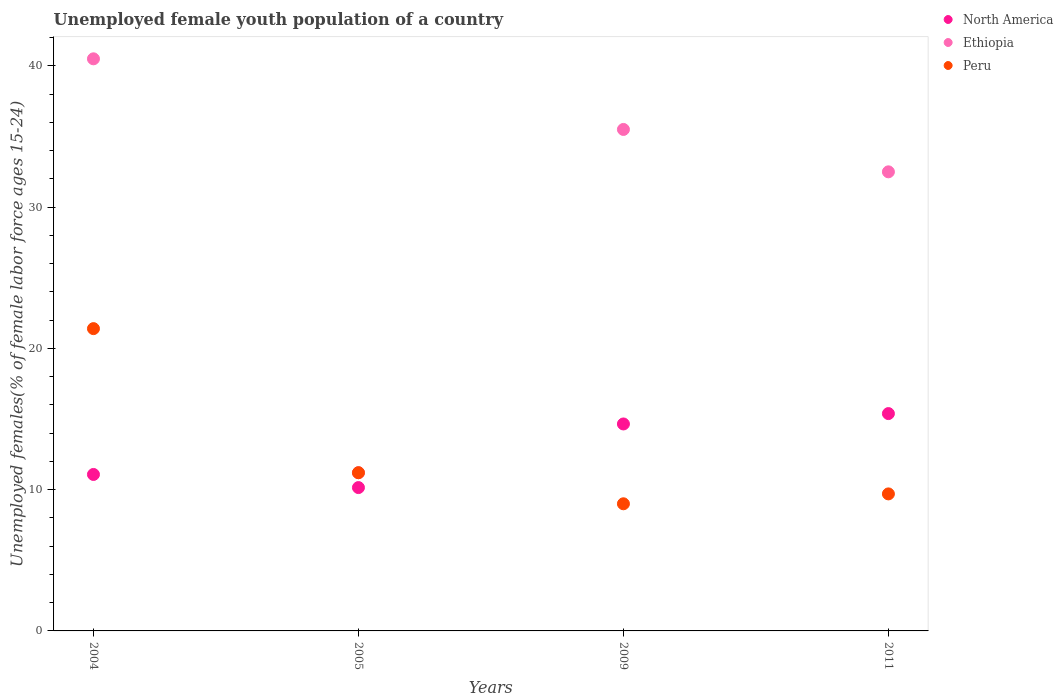Is the number of dotlines equal to the number of legend labels?
Give a very brief answer. Yes. What is the percentage of unemployed female youth population in Ethiopia in 2004?
Your response must be concise. 40.5. Across all years, what is the maximum percentage of unemployed female youth population in Peru?
Your answer should be very brief. 21.4. In which year was the percentage of unemployed female youth population in North America minimum?
Provide a succinct answer. 2005. What is the total percentage of unemployed female youth population in Peru in the graph?
Make the answer very short. 51.3. What is the difference between the percentage of unemployed female youth population in North America in 2005 and that in 2011?
Give a very brief answer. -5.24. What is the difference between the percentage of unemployed female youth population in North America in 2004 and the percentage of unemployed female youth population in Ethiopia in 2005?
Provide a short and direct response. -0.12. What is the average percentage of unemployed female youth population in Ethiopia per year?
Your answer should be very brief. 29.92. In the year 2009, what is the difference between the percentage of unemployed female youth population in Ethiopia and percentage of unemployed female youth population in Peru?
Provide a succinct answer. 26.5. What is the ratio of the percentage of unemployed female youth population in North America in 2009 to that in 2011?
Give a very brief answer. 0.95. What is the difference between the highest and the second highest percentage of unemployed female youth population in North America?
Your answer should be compact. 0.73. What is the difference between the highest and the lowest percentage of unemployed female youth population in Ethiopia?
Give a very brief answer. 29.3. In how many years, is the percentage of unemployed female youth population in North America greater than the average percentage of unemployed female youth population in North America taken over all years?
Offer a very short reply. 2. Is the sum of the percentage of unemployed female youth population in North America in 2004 and 2005 greater than the maximum percentage of unemployed female youth population in Peru across all years?
Give a very brief answer. No. Does the percentage of unemployed female youth population in Ethiopia monotonically increase over the years?
Provide a succinct answer. No. What is the difference between two consecutive major ticks on the Y-axis?
Offer a very short reply. 10. Are the values on the major ticks of Y-axis written in scientific E-notation?
Provide a succinct answer. No. Does the graph contain any zero values?
Ensure brevity in your answer.  No. Does the graph contain grids?
Your answer should be very brief. No. How are the legend labels stacked?
Your answer should be compact. Vertical. What is the title of the graph?
Provide a succinct answer. Unemployed female youth population of a country. What is the label or title of the X-axis?
Your answer should be very brief. Years. What is the label or title of the Y-axis?
Your response must be concise. Unemployed females(% of female labor force ages 15-24). What is the Unemployed females(% of female labor force ages 15-24) in North America in 2004?
Provide a short and direct response. 11.08. What is the Unemployed females(% of female labor force ages 15-24) of Ethiopia in 2004?
Make the answer very short. 40.5. What is the Unemployed females(% of female labor force ages 15-24) in Peru in 2004?
Provide a succinct answer. 21.4. What is the Unemployed females(% of female labor force ages 15-24) of North America in 2005?
Offer a terse response. 10.15. What is the Unemployed females(% of female labor force ages 15-24) of Ethiopia in 2005?
Your response must be concise. 11.2. What is the Unemployed females(% of female labor force ages 15-24) of Peru in 2005?
Your response must be concise. 11.2. What is the Unemployed females(% of female labor force ages 15-24) in North America in 2009?
Provide a short and direct response. 14.65. What is the Unemployed females(% of female labor force ages 15-24) of Ethiopia in 2009?
Provide a succinct answer. 35.5. What is the Unemployed females(% of female labor force ages 15-24) in North America in 2011?
Keep it short and to the point. 15.39. What is the Unemployed females(% of female labor force ages 15-24) in Ethiopia in 2011?
Your answer should be very brief. 32.5. What is the Unemployed females(% of female labor force ages 15-24) of Peru in 2011?
Offer a terse response. 9.7. Across all years, what is the maximum Unemployed females(% of female labor force ages 15-24) in North America?
Ensure brevity in your answer.  15.39. Across all years, what is the maximum Unemployed females(% of female labor force ages 15-24) in Ethiopia?
Your answer should be very brief. 40.5. Across all years, what is the maximum Unemployed females(% of female labor force ages 15-24) of Peru?
Keep it short and to the point. 21.4. Across all years, what is the minimum Unemployed females(% of female labor force ages 15-24) in North America?
Offer a terse response. 10.15. Across all years, what is the minimum Unemployed females(% of female labor force ages 15-24) of Ethiopia?
Your answer should be compact. 11.2. What is the total Unemployed females(% of female labor force ages 15-24) of North America in the graph?
Your response must be concise. 51.26. What is the total Unemployed females(% of female labor force ages 15-24) of Ethiopia in the graph?
Ensure brevity in your answer.  119.7. What is the total Unemployed females(% of female labor force ages 15-24) of Peru in the graph?
Ensure brevity in your answer.  51.3. What is the difference between the Unemployed females(% of female labor force ages 15-24) in Ethiopia in 2004 and that in 2005?
Provide a short and direct response. 29.3. What is the difference between the Unemployed females(% of female labor force ages 15-24) in Peru in 2004 and that in 2005?
Your answer should be compact. 10.2. What is the difference between the Unemployed females(% of female labor force ages 15-24) of North America in 2004 and that in 2009?
Provide a succinct answer. -3.58. What is the difference between the Unemployed females(% of female labor force ages 15-24) in Ethiopia in 2004 and that in 2009?
Keep it short and to the point. 5. What is the difference between the Unemployed females(% of female labor force ages 15-24) in North America in 2004 and that in 2011?
Your response must be concise. -4.31. What is the difference between the Unemployed females(% of female labor force ages 15-24) in Peru in 2004 and that in 2011?
Provide a short and direct response. 11.7. What is the difference between the Unemployed females(% of female labor force ages 15-24) of North America in 2005 and that in 2009?
Offer a very short reply. -4.5. What is the difference between the Unemployed females(% of female labor force ages 15-24) of Ethiopia in 2005 and that in 2009?
Your response must be concise. -24.3. What is the difference between the Unemployed females(% of female labor force ages 15-24) in North America in 2005 and that in 2011?
Your response must be concise. -5.24. What is the difference between the Unemployed females(% of female labor force ages 15-24) in Ethiopia in 2005 and that in 2011?
Keep it short and to the point. -21.3. What is the difference between the Unemployed females(% of female labor force ages 15-24) of Peru in 2005 and that in 2011?
Make the answer very short. 1.5. What is the difference between the Unemployed females(% of female labor force ages 15-24) of North America in 2009 and that in 2011?
Give a very brief answer. -0.73. What is the difference between the Unemployed females(% of female labor force ages 15-24) of Ethiopia in 2009 and that in 2011?
Your response must be concise. 3. What is the difference between the Unemployed females(% of female labor force ages 15-24) in Peru in 2009 and that in 2011?
Your response must be concise. -0.7. What is the difference between the Unemployed females(% of female labor force ages 15-24) of North America in 2004 and the Unemployed females(% of female labor force ages 15-24) of Ethiopia in 2005?
Your answer should be very brief. -0.12. What is the difference between the Unemployed females(% of female labor force ages 15-24) in North America in 2004 and the Unemployed females(% of female labor force ages 15-24) in Peru in 2005?
Keep it short and to the point. -0.12. What is the difference between the Unemployed females(% of female labor force ages 15-24) of Ethiopia in 2004 and the Unemployed females(% of female labor force ages 15-24) of Peru in 2005?
Your answer should be very brief. 29.3. What is the difference between the Unemployed females(% of female labor force ages 15-24) in North America in 2004 and the Unemployed females(% of female labor force ages 15-24) in Ethiopia in 2009?
Offer a terse response. -24.42. What is the difference between the Unemployed females(% of female labor force ages 15-24) of North America in 2004 and the Unemployed females(% of female labor force ages 15-24) of Peru in 2009?
Make the answer very short. 2.08. What is the difference between the Unemployed females(% of female labor force ages 15-24) of Ethiopia in 2004 and the Unemployed females(% of female labor force ages 15-24) of Peru in 2009?
Offer a very short reply. 31.5. What is the difference between the Unemployed females(% of female labor force ages 15-24) in North America in 2004 and the Unemployed females(% of female labor force ages 15-24) in Ethiopia in 2011?
Your response must be concise. -21.42. What is the difference between the Unemployed females(% of female labor force ages 15-24) in North America in 2004 and the Unemployed females(% of female labor force ages 15-24) in Peru in 2011?
Make the answer very short. 1.38. What is the difference between the Unemployed females(% of female labor force ages 15-24) in Ethiopia in 2004 and the Unemployed females(% of female labor force ages 15-24) in Peru in 2011?
Your answer should be compact. 30.8. What is the difference between the Unemployed females(% of female labor force ages 15-24) of North America in 2005 and the Unemployed females(% of female labor force ages 15-24) of Ethiopia in 2009?
Your response must be concise. -25.35. What is the difference between the Unemployed females(% of female labor force ages 15-24) of North America in 2005 and the Unemployed females(% of female labor force ages 15-24) of Peru in 2009?
Give a very brief answer. 1.15. What is the difference between the Unemployed females(% of female labor force ages 15-24) of North America in 2005 and the Unemployed females(% of female labor force ages 15-24) of Ethiopia in 2011?
Offer a terse response. -22.35. What is the difference between the Unemployed females(% of female labor force ages 15-24) of North America in 2005 and the Unemployed females(% of female labor force ages 15-24) of Peru in 2011?
Your answer should be very brief. 0.45. What is the difference between the Unemployed females(% of female labor force ages 15-24) in Ethiopia in 2005 and the Unemployed females(% of female labor force ages 15-24) in Peru in 2011?
Your answer should be very brief. 1.5. What is the difference between the Unemployed females(% of female labor force ages 15-24) in North America in 2009 and the Unemployed females(% of female labor force ages 15-24) in Ethiopia in 2011?
Make the answer very short. -17.85. What is the difference between the Unemployed females(% of female labor force ages 15-24) of North America in 2009 and the Unemployed females(% of female labor force ages 15-24) of Peru in 2011?
Provide a succinct answer. 4.95. What is the difference between the Unemployed females(% of female labor force ages 15-24) in Ethiopia in 2009 and the Unemployed females(% of female labor force ages 15-24) in Peru in 2011?
Offer a terse response. 25.8. What is the average Unemployed females(% of female labor force ages 15-24) of North America per year?
Your response must be concise. 12.81. What is the average Unemployed females(% of female labor force ages 15-24) in Ethiopia per year?
Your answer should be compact. 29.93. What is the average Unemployed females(% of female labor force ages 15-24) of Peru per year?
Provide a succinct answer. 12.82. In the year 2004, what is the difference between the Unemployed females(% of female labor force ages 15-24) of North America and Unemployed females(% of female labor force ages 15-24) of Ethiopia?
Offer a terse response. -29.42. In the year 2004, what is the difference between the Unemployed females(% of female labor force ages 15-24) of North America and Unemployed females(% of female labor force ages 15-24) of Peru?
Offer a very short reply. -10.32. In the year 2005, what is the difference between the Unemployed females(% of female labor force ages 15-24) of North America and Unemployed females(% of female labor force ages 15-24) of Ethiopia?
Keep it short and to the point. -1.05. In the year 2005, what is the difference between the Unemployed females(% of female labor force ages 15-24) in North America and Unemployed females(% of female labor force ages 15-24) in Peru?
Make the answer very short. -1.05. In the year 2005, what is the difference between the Unemployed females(% of female labor force ages 15-24) in Ethiopia and Unemployed females(% of female labor force ages 15-24) in Peru?
Keep it short and to the point. 0. In the year 2009, what is the difference between the Unemployed females(% of female labor force ages 15-24) of North America and Unemployed females(% of female labor force ages 15-24) of Ethiopia?
Ensure brevity in your answer.  -20.85. In the year 2009, what is the difference between the Unemployed females(% of female labor force ages 15-24) in North America and Unemployed females(% of female labor force ages 15-24) in Peru?
Your answer should be compact. 5.65. In the year 2009, what is the difference between the Unemployed females(% of female labor force ages 15-24) of Ethiopia and Unemployed females(% of female labor force ages 15-24) of Peru?
Keep it short and to the point. 26.5. In the year 2011, what is the difference between the Unemployed females(% of female labor force ages 15-24) in North America and Unemployed females(% of female labor force ages 15-24) in Ethiopia?
Keep it short and to the point. -17.11. In the year 2011, what is the difference between the Unemployed females(% of female labor force ages 15-24) in North America and Unemployed females(% of female labor force ages 15-24) in Peru?
Your answer should be compact. 5.69. In the year 2011, what is the difference between the Unemployed females(% of female labor force ages 15-24) in Ethiopia and Unemployed females(% of female labor force ages 15-24) in Peru?
Make the answer very short. 22.8. What is the ratio of the Unemployed females(% of female labor force ages 15-24) in North America in 2004 to that in 2005?
Keep it short and to the point. 1.09. What is the ratio of the Unemployed females(% of female labor force ages 15-24) in Ethiopia in 2004 to that in 2005?
Offer a very short reply. 3.62. What is the ratio of the Unemployed females(% of female labor force ages 15-24) of Peru in 2004 to that in 2005?
Your answer should be compact. 1.91. What is the ratio of the Unemployed females(% of female labor force ages 15-24) in North America in 2004 to that in 2009?
Keep it short and to the point. 0.76. What is the ratio of the Unemployed females(% of female labor force ages 15-24) in Ethiopia in 2004 to that in 2009?
Offer a very short reply. 1.14. What is the ratio of the Unemployed females(% of female labor force ages 15-24) of Peru in 2004 to that in 2009?
Keep it short and to the point. 2.38. What is the ratio of the Unemployed females(% of female labor force ages 15-24) in North America in 2004 to that in 2011?
Offer a very short reply. 0.72. What is the ratio of the Unemployed females(% of female labor force ages 15-24) in Ethiopia in 2004 to that in 2011?
Your answer should be very brief. 1.25. What is the ratio of the Unemployed females(% of female labor force ages 15-24) of Peru in 2004 to that in 2011?
Make the answer very short. 2.21. What is the ratio of the Unemployed females(% of female labor force ages 15-24) in North America in 2005 to that in 2009?
Your answer should be compact. 0.69. What is the ratio of the Unemployed females(% of female labor force ages 15-24) of Ethiopia in 2005 to that in 2009?
Your answer should be very brief. 0.32. What is the ratio of the Unemployed females(% of female labor force ages 15-24) in Peru in 2005 to that in 2009?
Your answer should be very brief. 1.24. What is the ratio of the Unemployed females(% of female labor force ages 15-24) of North America in 2005 to that in 2011?
Your answer should be very brief. 0.66. What is the ratio of the Unemployed females(% of female labor force ages 15-24) in Ethiopia in 2005 to that in 2011?
Offer a terse response. 0.34. What is the ratio of the Unemployed females(% of female labor force ages 15-24) of Peru in 2005 to that in 2011?
Offer a terse response. 1.15. What is the ratio of the Unemployed females(% of female labor force ages 15-24) of North America in 2009 to that in 2011?
Make the answer very short. 0.95. What is the ratio of the Unemployed females(% of female labor force ages 15-24) of Ethiopia in 2009 to that in 2011?
Ensure brevity in your answer.  1.09. What is the ratio of the Unemployed females(% of female labor force ages 15-24) in Peru in 2009 to that in 2011?
Your response must be concise. 0.93. What is the difference between the highest and the second highest Unemployed females(% of female labor force ages 15-24) in North America?
Keep it short and to the point. 0.73. What is the difference between the highest and the second highest Unemployed females(% of female labor force ages 15-24) in Ethiopia?
Provide a succinct answer. 5. What is the difference between the highest and the second highest Unemployed females(% of female labor force ages 15-24) in Peru?
Your answer should be compact. 10.2. What is the difference between the highest and the lowest Unemployed females(% of female labor force ages 15-24) in North America?
Offer a very short reply. 5.24. What is the difference between the highest and the lowest Unemployed females(% of female labor force ages 15-24) of Ethiopia?
Make the answer very short. 29.3. 